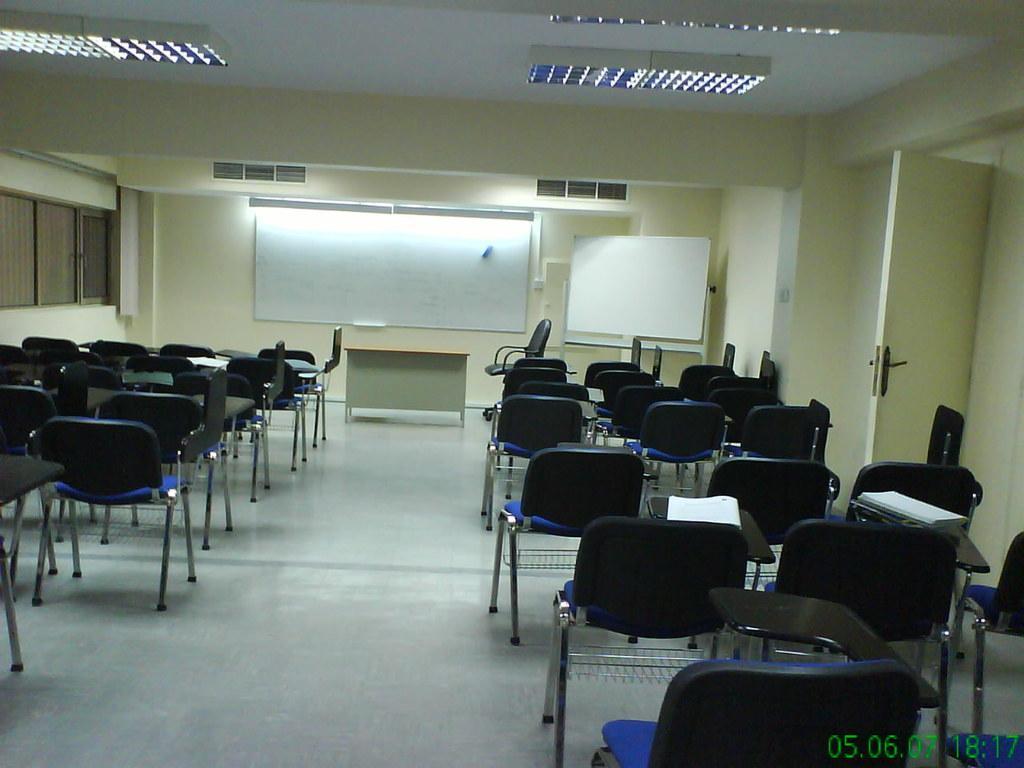Can you describe this image briefly? As we can see in the image there is a wall, window, board, door and few chairs on floor. 